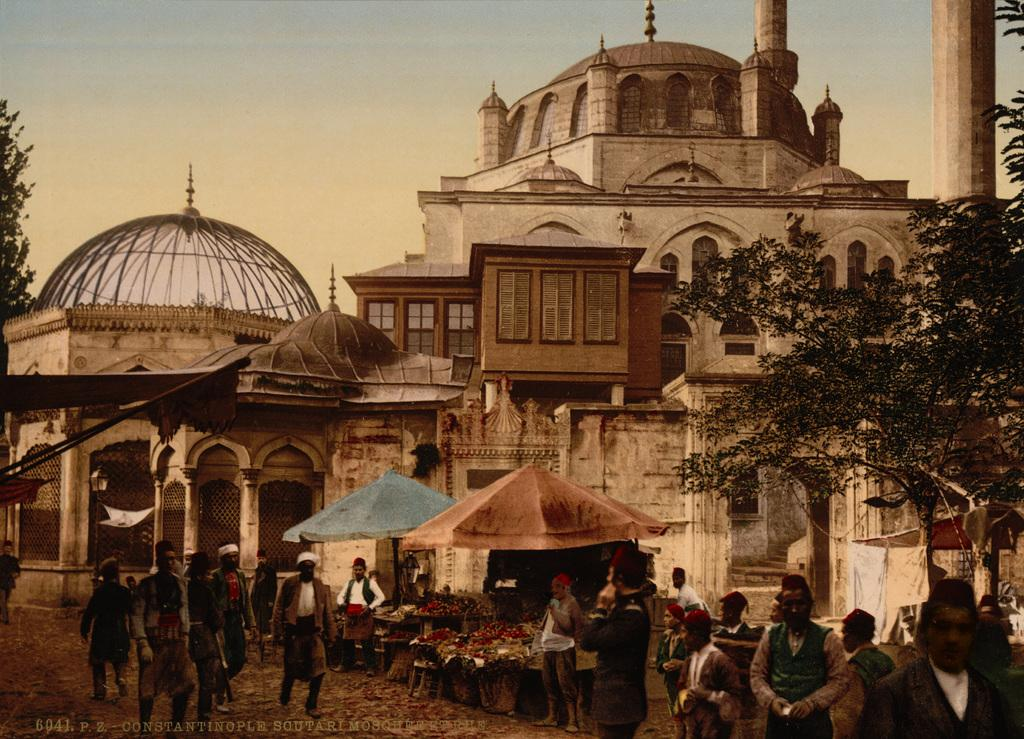How many people are in the image? There is a group of people in the image, but the exact number cannot be determined from the provided facts. What can be seen in the background of the image? There are tents, trees, and buildings in the background of the image. What is present in the bottom left hand corner of the image? There is some text in the bottom left hand corner of the image. What type of coat is the person wearing on the hill in the image? There is no hill or person wearing a coat in the image. 